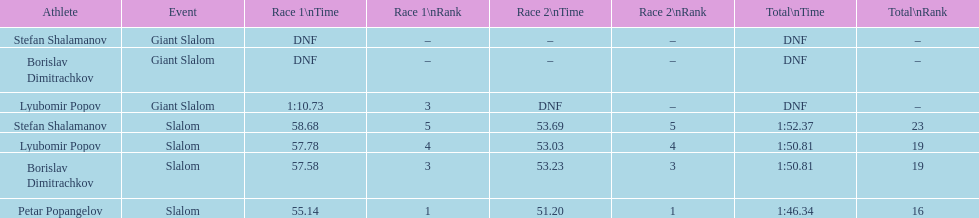What is the rank number of stefan shalamanov in the slalom event 23. 